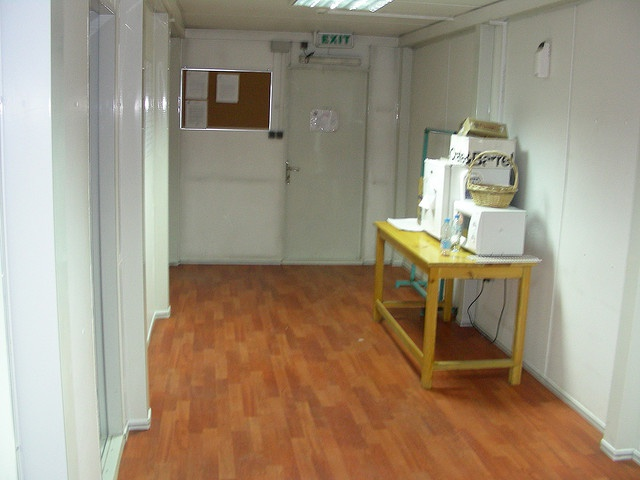Describe the objects in this image and their specific colors. I can see dining table in lightblue, olive, maroon, and gray tones and microwave in lightblue, lightgray, ivory, and darkgray tones in this image. 